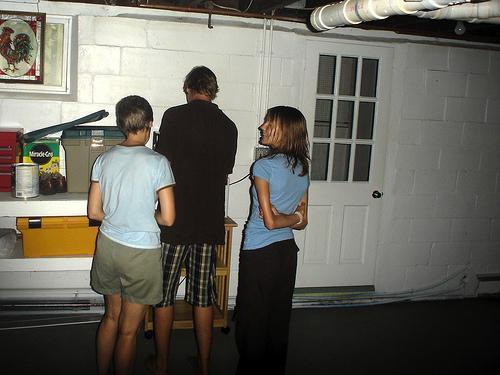How many people are there?
Give a very brief answer. 3. 